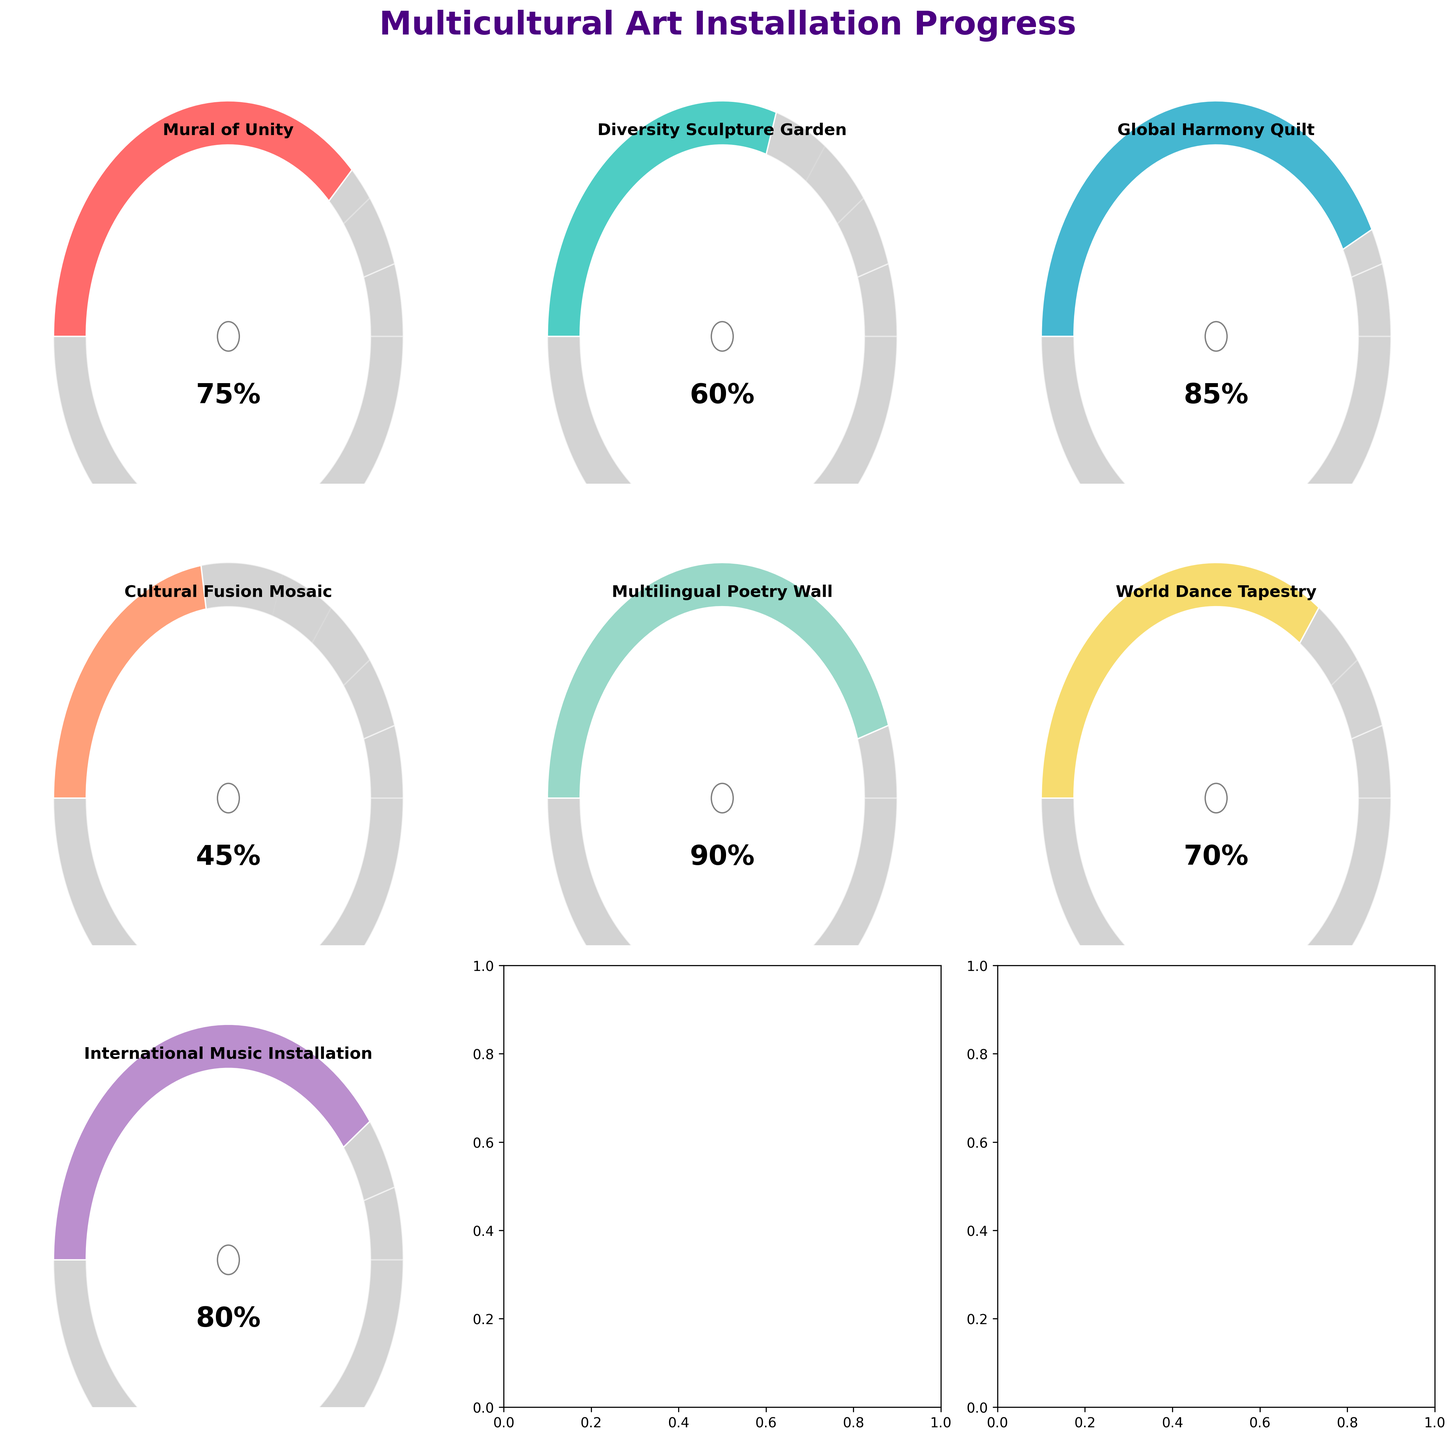Which project has the highest progress percentage? The figure shows the progress percentages for each project. The Multilingual Poetry Wall stands out with the highest progress at 90%.
Answer: Multilingual Poetry Wall What's the title of the figure? The title is displayed at the top of the figure and reads "Multicultural Art Installation Progress".
Answer: Multicultural Art Installation Progress What color is used to represent the Global Harmony Quilt project? Each project is represented by a distinct color. The Global Harmony Quilt is shown in a different vibrant color which is light blue.
Answer: Light blue How much more progress does the Global Harmony Quilt have compared to the Cultural Fusion Mosaic? The Global Harmony Quilt has 85% progress and the Cultural Fusion Mosaic has 45%. The difference is calculated by subtracting 45 from 85. 85 - 45 = 40.
Answer: 40% Which project has achieved more than 70% progress but less than 85%? From the figure, the Mural of Unity is at 75% and the World Dance Tapestry is at 70%. Only the Mural of Unity fits the criteria of being more than 70% but less than 85%.
Answer: Mural of Unity Add the progress percentages of the World Dance Tapestry and Diversity Sculpture Garden From the figure, the World Dance Tapestry shows 70% and the Diversity Sculpture Garden shows 60%. Adding these gives 70 + 60 = 130.
Answer: 130% How many projects have progress percentages above 80%? By checking the figure, the Global Harmony Quilt, Multilingual Poetry Wall, and International Music Installation have progress percentages of 85%, 90%, and 80% respectively. So, there are 3 projects with progress percentages above 80%.
Answer: 3 What is the average progress of all projects? Sum up all the progress percentages: 75 + 60 + 85 + 45 + 90 + 70 + 80 = 505. There are 7 projects, so the average is 505 / 7 ≈ 72.14.
Answer: 72.14% Which project has the least progress? By examining all the percentage values, the Cultural Fusion Mosaic has the lowest progress at 45%.
Answer: Cultural Fusion Mosaic Compare the progress of International Music Installation and World Dance Tapestry. According to the figure, International Music Installation has 80% progress, while the World Dance Tapestry has 70%. The International Music Installation has more progress.
Answer: International Music Installation 